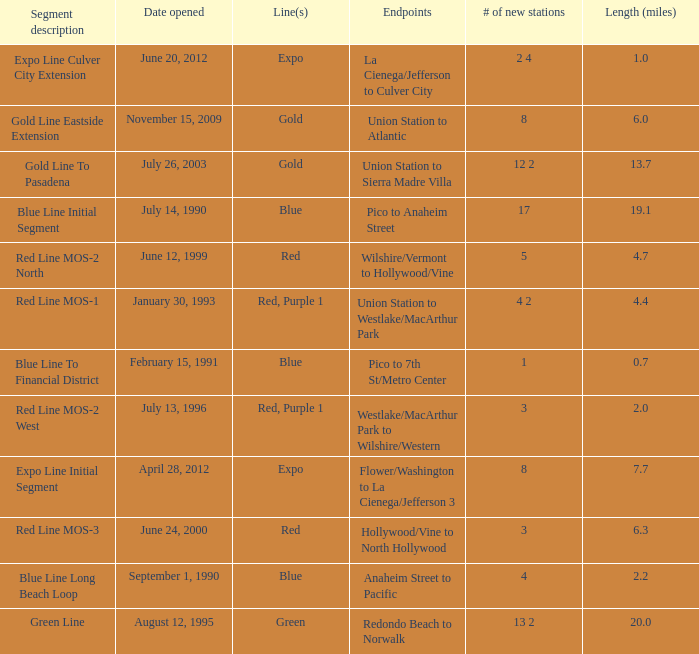What is the length  (miles) when pico to 7th st/metro center are the endpoints? 0.7. 